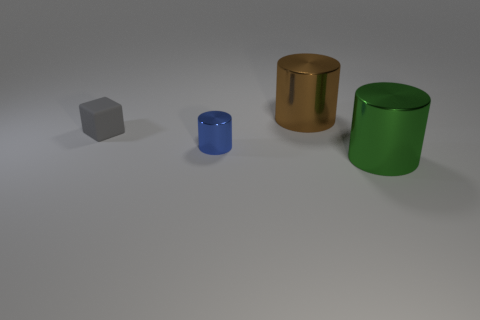Is there a small green thing of the same shape as the big brown object?
Your answer should be very brief. No. How many small green metallic things are there?
Provide a short and direct response. 0. Is the material of the cylinder that is behind the blue cylinder the same as the gray thing?
Ensure brevity in your answer.  No. Are there any blue things that have the same size as the blue cylinder?
Make the answer very short. No. There is a brown object; does it have the same shape as the metallic object that is in front of the tiny blue object?
Ensure brevity in your answer.  Yes. There is a metal thing that is left of the shiny cylinder that is behind the small gray rubber thing; are there any tiny gray matte cubes that are behind it?
Keep it short and to the point. Yes. What is the size of the green shiny cylinder?
Provide a succinct answer. Large. There is a big object in front of the large brown metallic thing; is it the same shape as the gray rubber thing?
Your answer should be very brief. No. What color is the other large metallic object that is the same shape as the big brown shiny object?
Offer a very short reply. Green. Is there anything else that has the same material as the small gray block?
Give a very brief answer. No. 